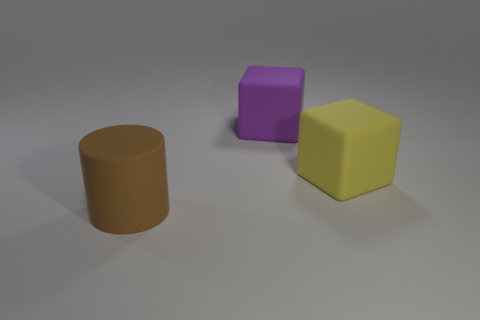Add 3 brown matte objects. How many objects exist? 6 Subtract all cubes. How many objects are left? 1 Add 2 large yellow matte cubes. How many large yellow matte cubes are left? 3 Add 3 big brown spheres. How many big brown spheres exist? 3 Subtract 0 blue cylinders. How many objects are left? 3 Subtract all red cylinders. Subtract all large brown cylinders. How many objects are left? 2 